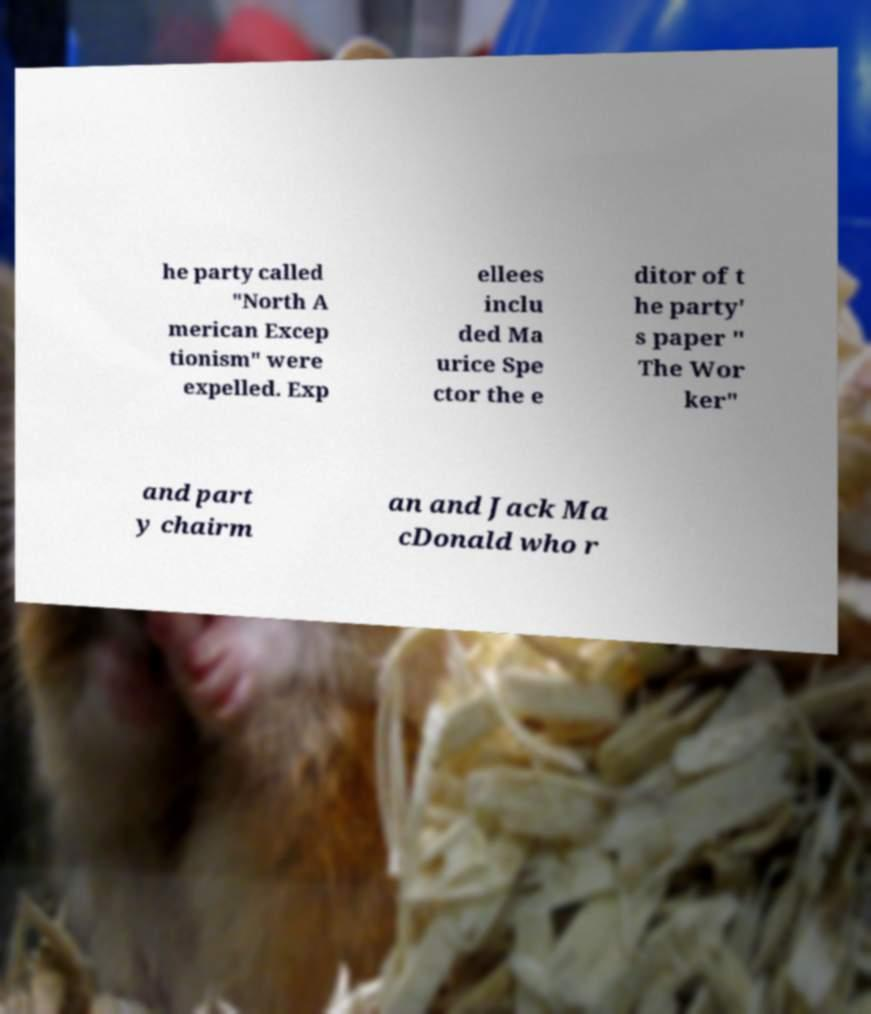I need the written content from this picture converted into text. Can you do that? he party called "North A merican Excep tionism" were expelled. Exp ellees inclu ded Ma urice Spe ctor the e ditor of t he party' s paper " The Wor ker" and part y chairm an and Jack Ma cDonald who r 